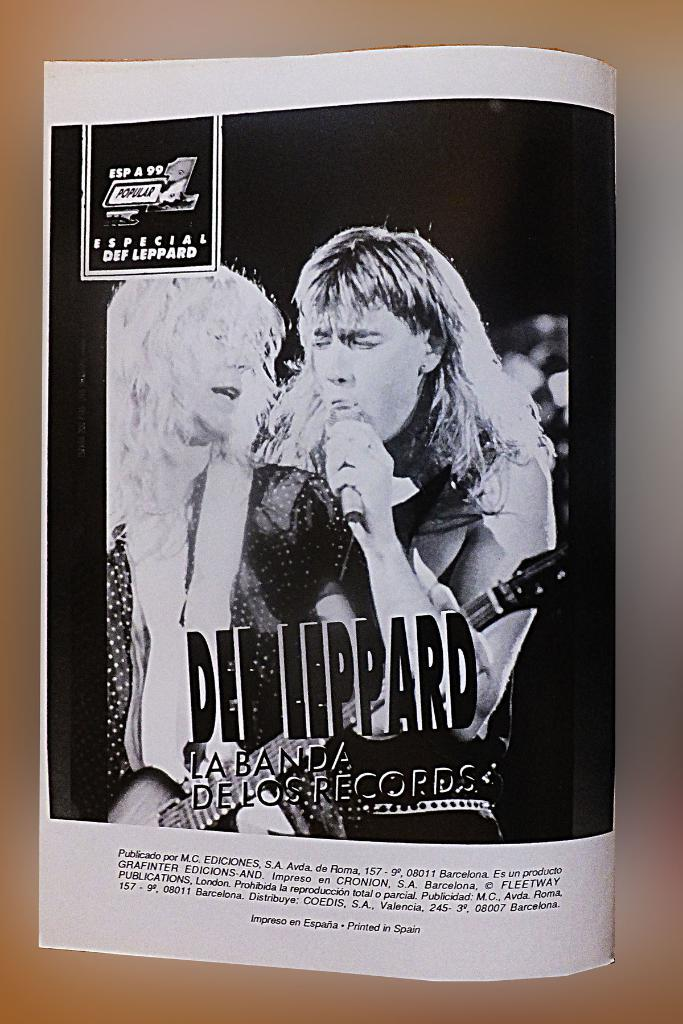<image>
Offer a succinct explanation of the picture presented. a black and white picture of the band Def Leppard 